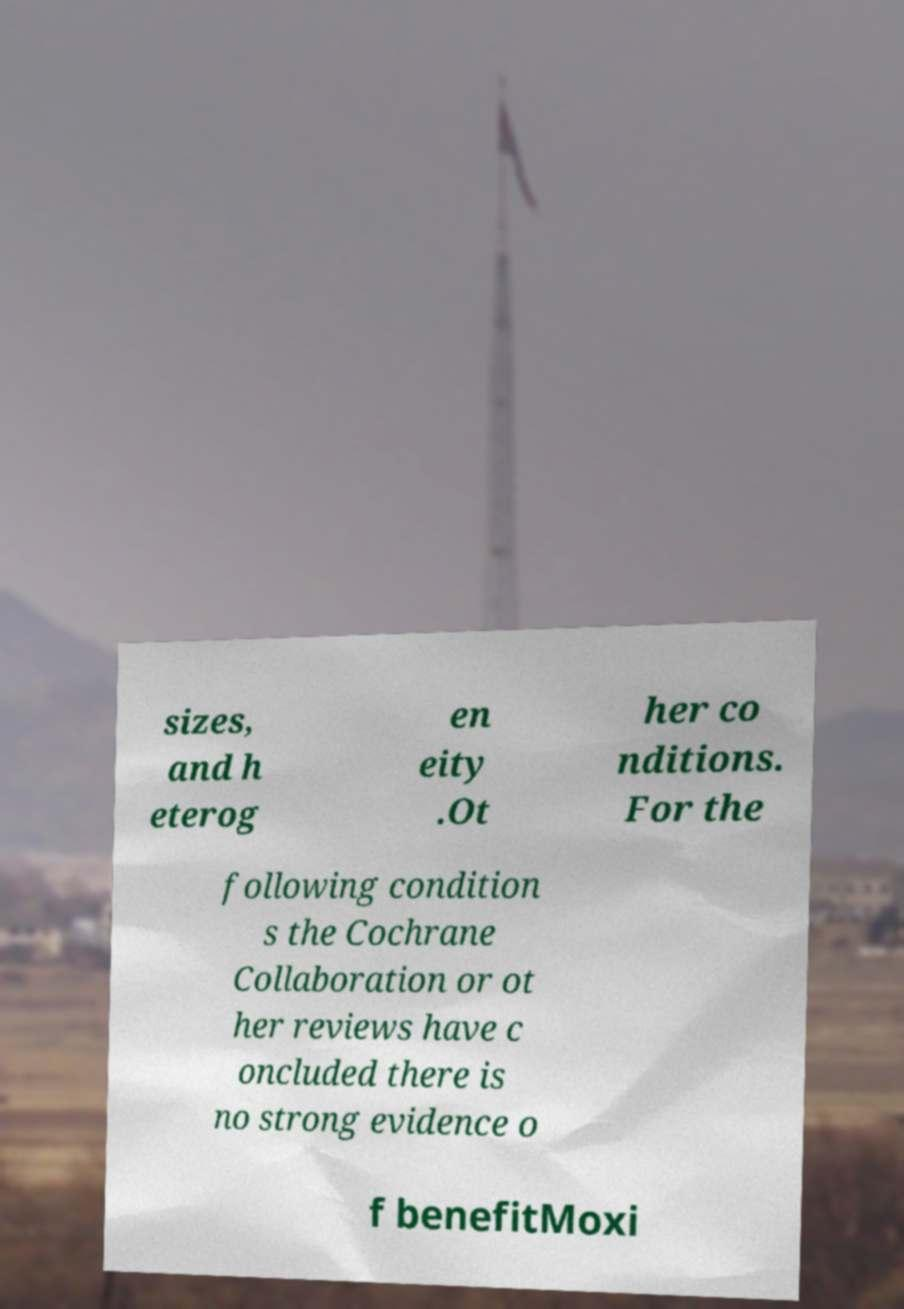Can you accurately transcribe the text from the provided image for me? sizes, and h eterog en eity .Ot her co nditions. For the following condition s the Cochrane Collaboration or ot her reviews have c oncluded there is no strong evidence o f benefitMoxi 